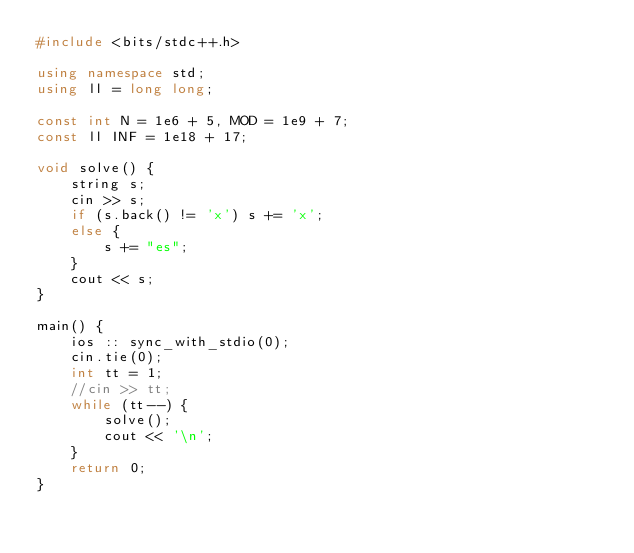Convert code to text. <code><loc_0><loc_0><loc_500><loc_500><_C++_>#include <bits/stdc++.h>

using namespace std;
using ll = long long;

const int N = 1e6 + 5, MOD = 1e9 + 7;
const ll INF = 1e18 + 17;

void solve() {
	string s;
	cin >> s;
	if (s.back() != 'x') s += 'x';
	else {
		s += "es";
	} 
	cout << s;
}

main() {
	ios :: sync_with_stdio(0);		
	cin.tie(0);
	int tt = 1;
	//cin >> tt;
	while (tt--) {
		solve();
		cout << '\n';
	} 
	return 0;
}</code> 